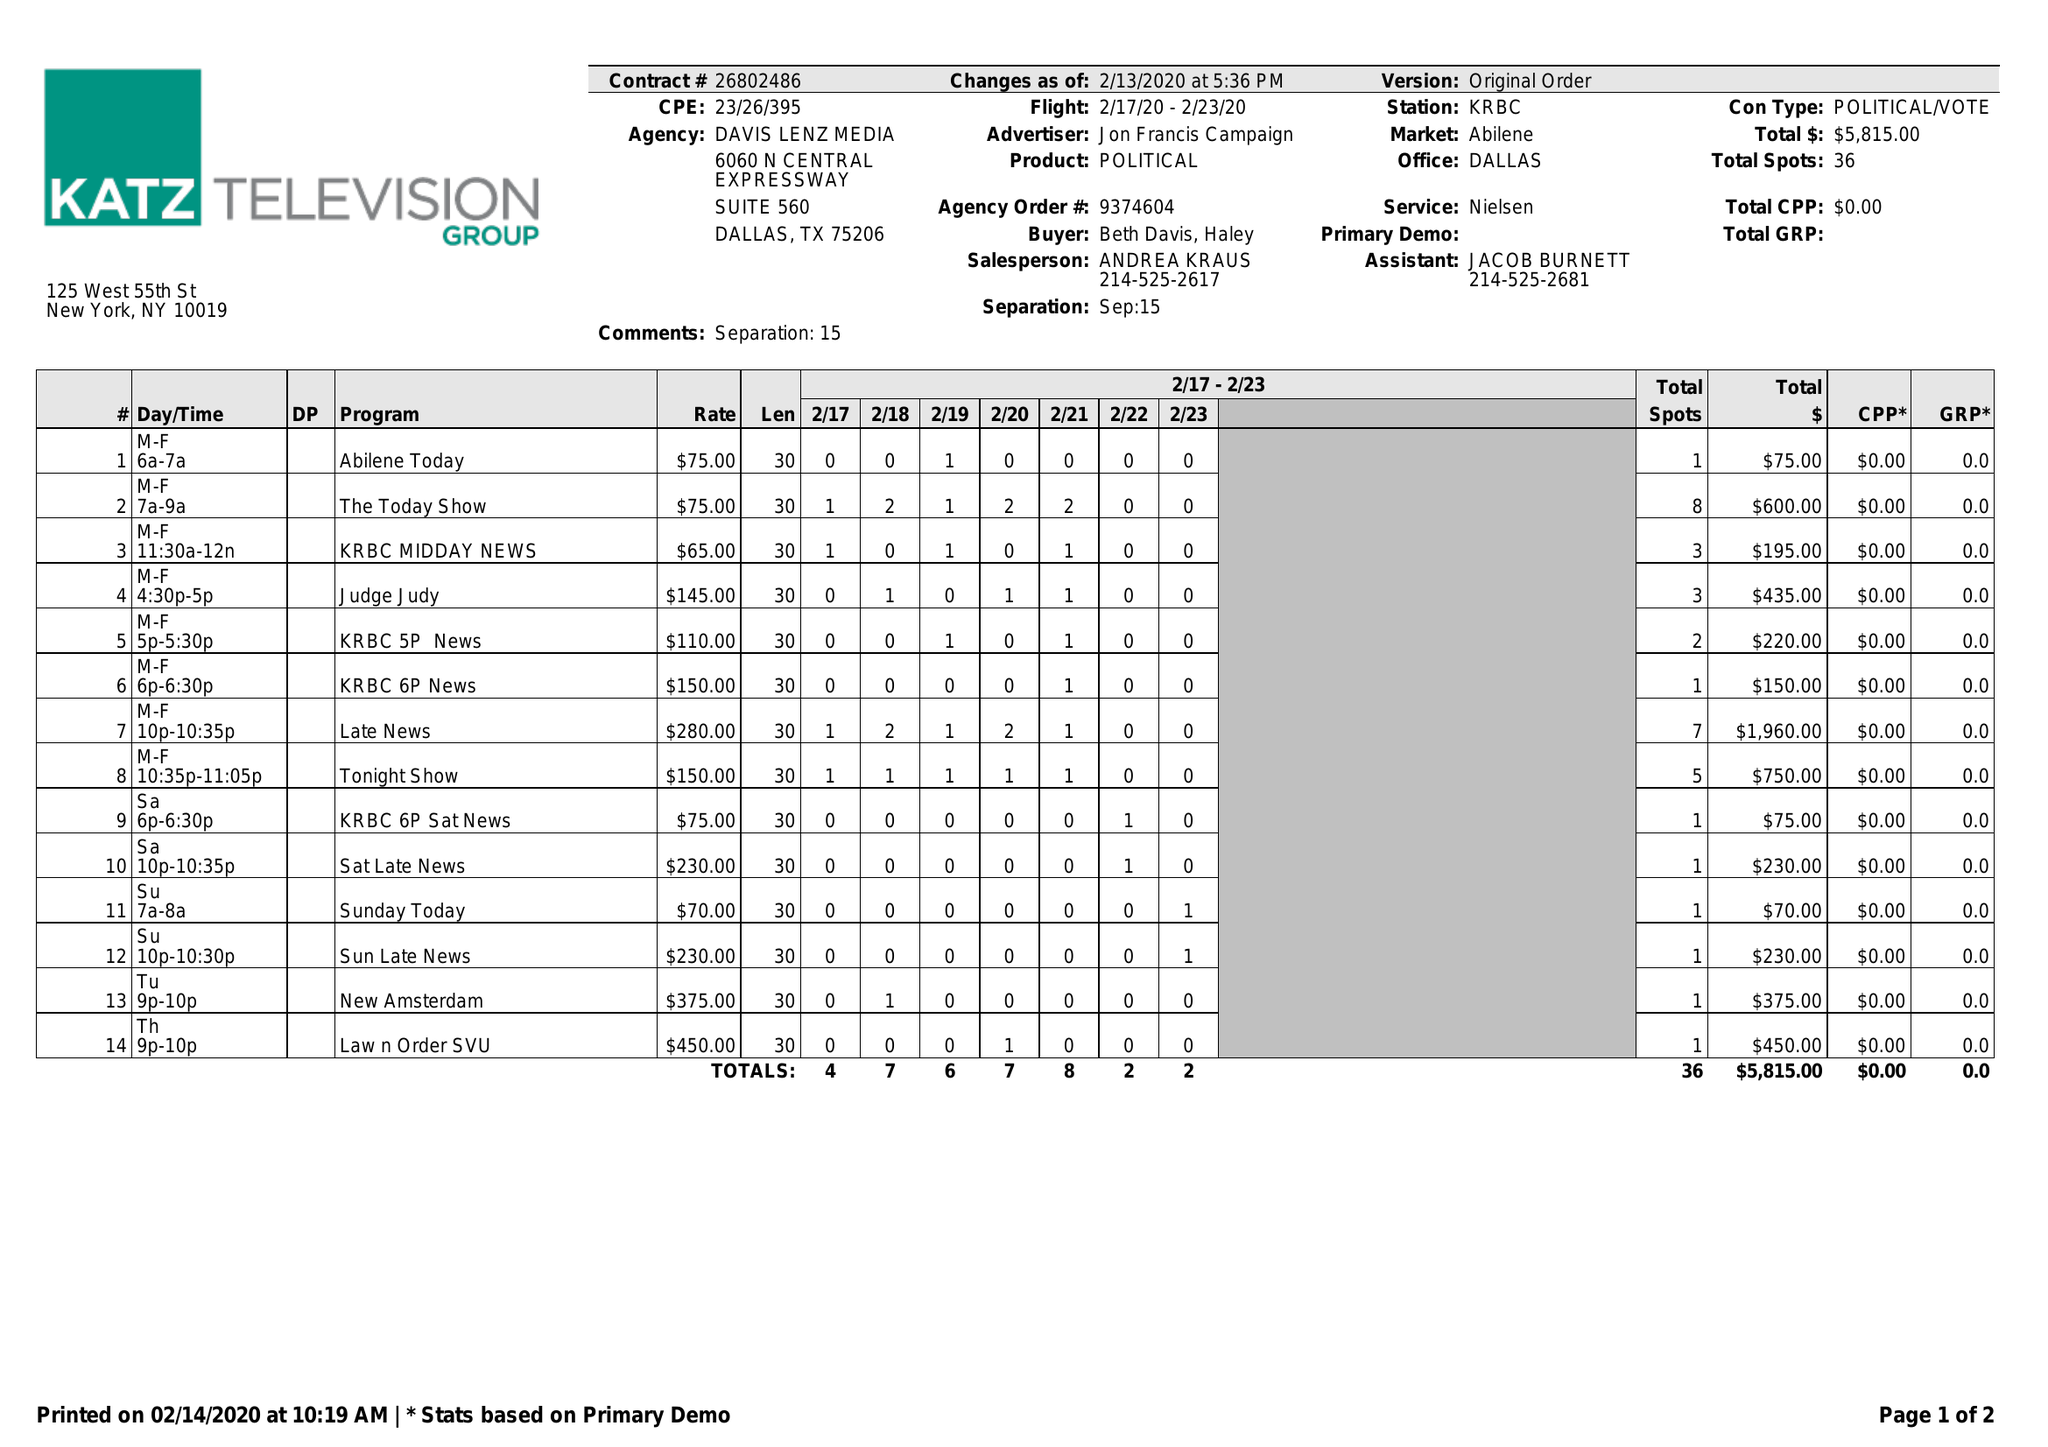What is the value for the flight_to?
Answer the question using a single word or phrase. 02/23/20 